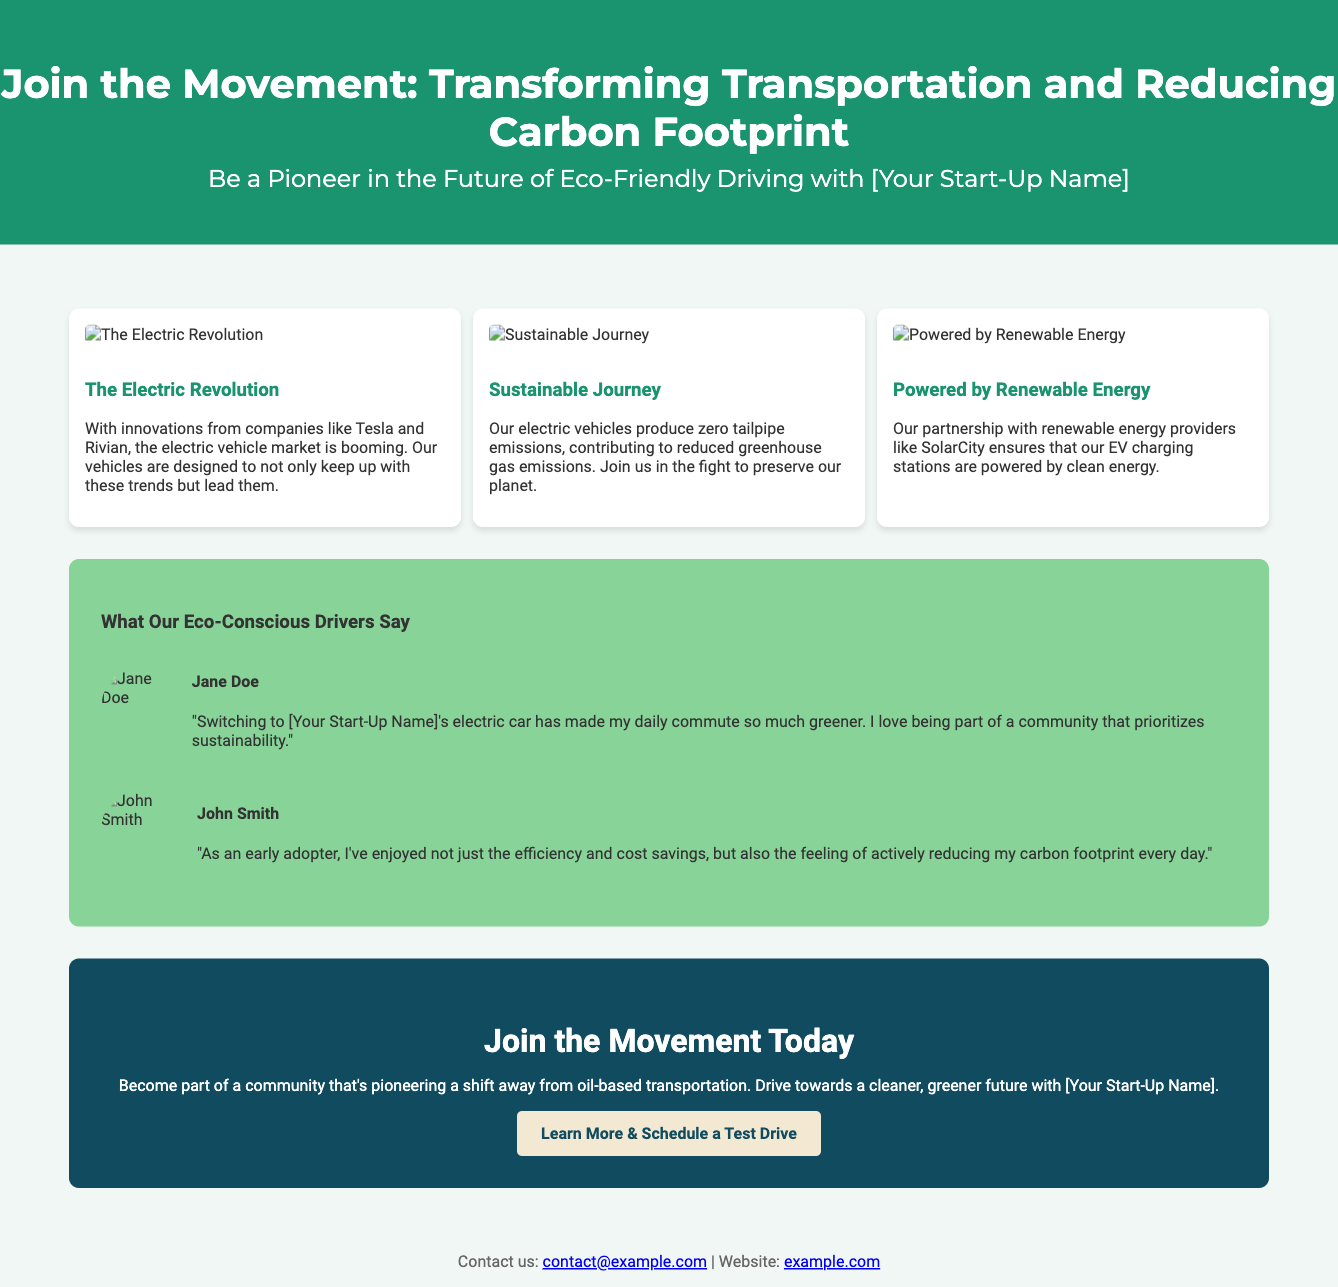What is the title of the advertisement? The title of the advertisement is prominently displayed in the header section of the document.
Answer: Join the Movement: Transforming Transportation and Reducing Carbon Footprint What are the names of the customer stories featured? The names of the customers who provided stories are presented alongside their testimonials.
Answer: Jane Doe, John Smith What color is used for the CTA button's default state? The background color of the CTA button in its default state is noted in the CSS styling.
Answer: Light beige How many visual narratives are included in the advertisement? The advertisement is structured to include multiple sections, with a specific count of visual narrative blocks.
Answer: Three Which renewable energy provider is mentioned in the document? The document specifies a partnership in relation to renewable energy providers to support clean charging.
Answer: SolarCity What type of emissions do the electric vehicles produce? The text states the environmental impact of the vehicles regarding emissions in a specific phrasing.
Answer: Zero tailpipe emissions What is the purpose of the CTA section? The CTA (Call to Action) section encourages engagement and outlines the community-based initiative.
Answer: Join the Movement Today How does the advertisement describe the community of drivers? The advertisement focuses on the collective aspect of drivers associated with eco-friendly initiatives.
Answer: Eco-conscious What is the background color of the customer stories section? The CSS defines specific color attributes for different sections which indicates the appearance of the customer stories area.
Answer: Light green 